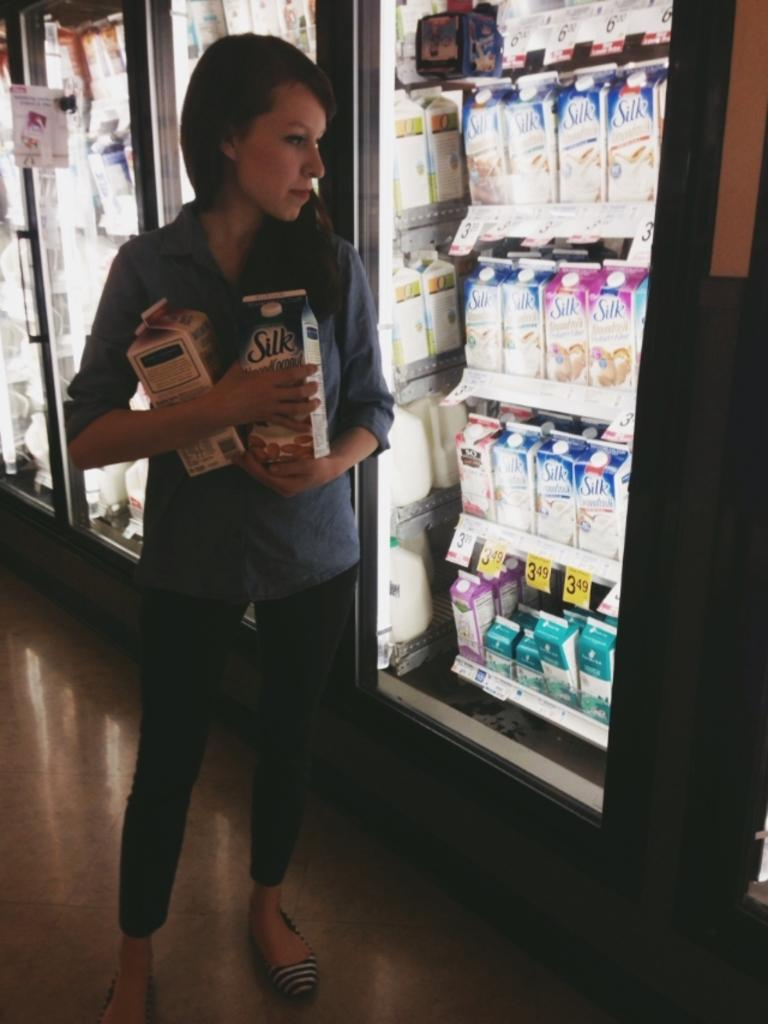<image>
Create a compact narrative representing the image presented. A woman stands in front of a milk fridge holding a carton of Silk milk in her hand. 